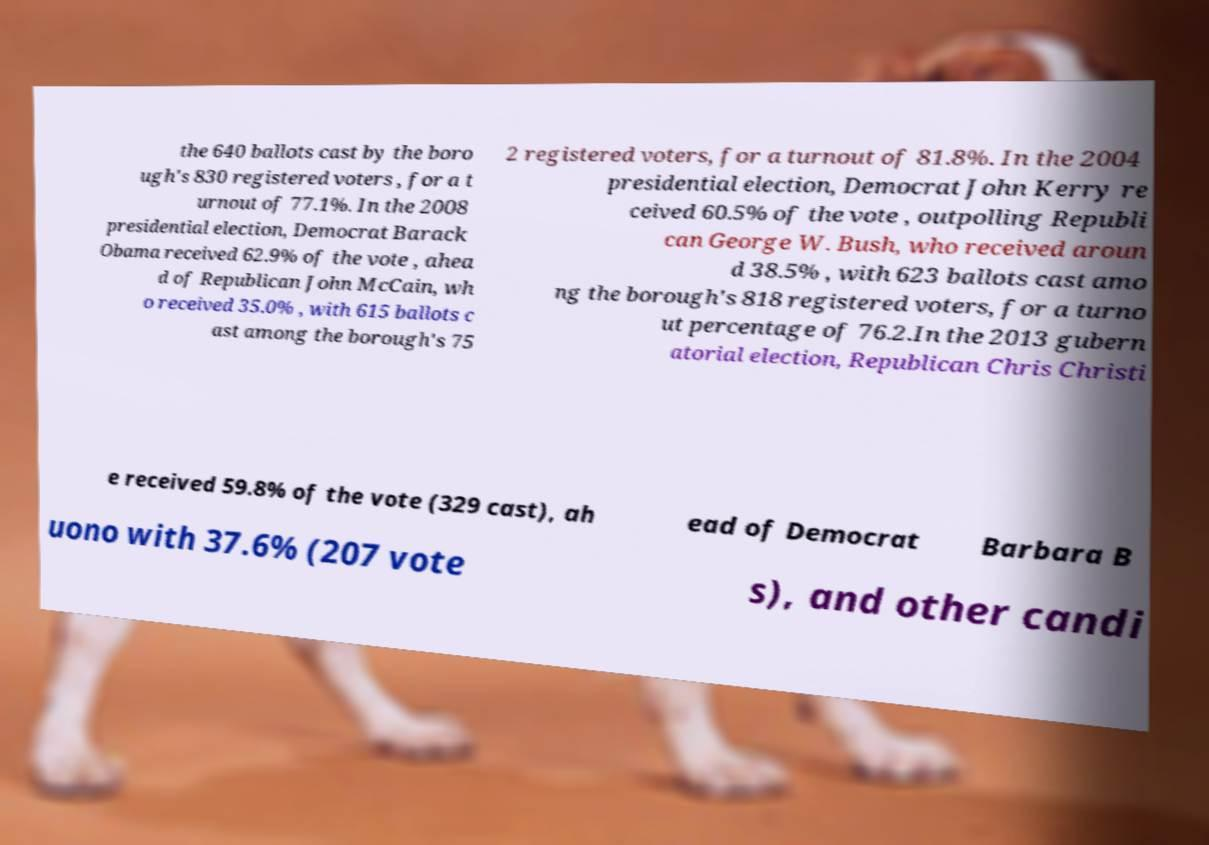Can you accurately transcribe the text from the provided image for me? the 640 ballots cast by the boro ugh's 830 registered voters , for a t urnout of 77.1%. In the 2008 presidential election, Democrat Barack Obama received 62.9% of the vote , ahea d of Republican John McCain, wh o received 35.0% , with 615 ballots c ast among the borough's 75 2 registered voters, for a turnout of 81.8%. In the 2004 presidential election, Democrat John Kerry re ceived 60.5% of the vote , outpolling Republi can George W. Bush, who received aroun d 38.5% , with 623 ballots cast amo ng the borough's 818 registered voters, for a turno ut percentage of 76.2.In the 2013 gubern atorial election, Republican Chris Christi e received 59.8% of the vote (329 cast), ah ead of Democrat Barbara B uono with 37.6% (207 vote s), and other candi 